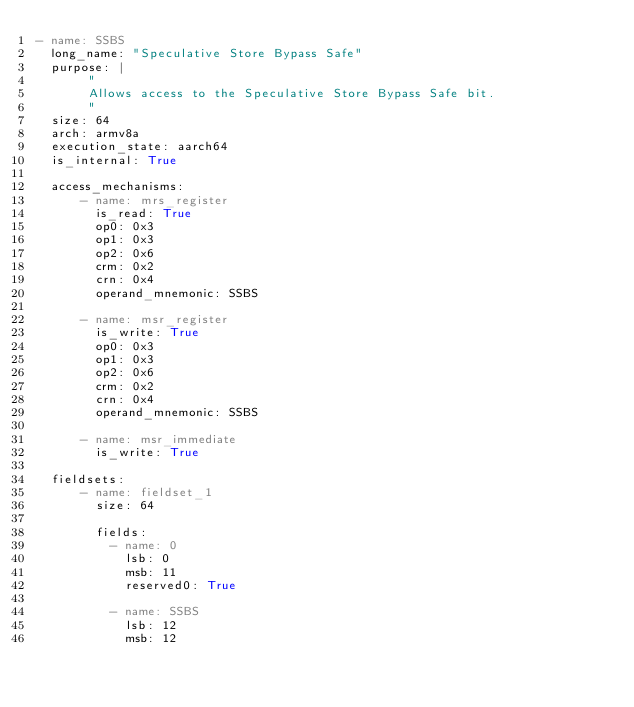<code> <loc_0><loc_0><loc_500><loc_500><_YAML_>- name: SSBS
  long_name: "Speculative Store Bypass Safe"
  purpose: |
       "
       Allows access to the Speculative Store Bypass Safe bit.
       "
  size: 64
  arch: armv8a
  execution_state: aarch64
  is_internal: True

  access_mechanisms:
      - name: mrs_register
        is_read: True
        op0: 0x3
        op1: 0x3
        op2: 0x6
        crm: 0x2
        crn: 0x4
        operand_mnemonic: SSBS

      - name: msr_register
        is_write: True
        op0: 0x3
        op1: 0x3
        op2: 0x6
        crm: 0x2
        crn: 0x4
        operand_mnemonic: SSBS

      - name: msr_immediate
        is_write: True

  fieldsets:
      - name: fieldset_1
        size: 64

        fields:
          - name: 0
            lsb: 0
            msb: 11
            reserved0: True

          - name: SSBS
            lsb: 12
            msb: 12
</code> 